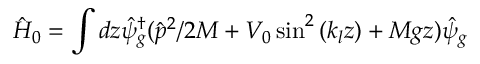<formula> <loc_0><loc_0><loc_500><loc_500>\hat { H } _ { 0 } = \int d z \hat { \psi } _ { g } ^ { \dagger } ( \hat { p } ^ { 2 } / 2 M + V _ { 0 } \sin ^ { 2 } \left ( k _ { l } z \right ) + M g z ) \hat { \psi } _ { g }</formula> 